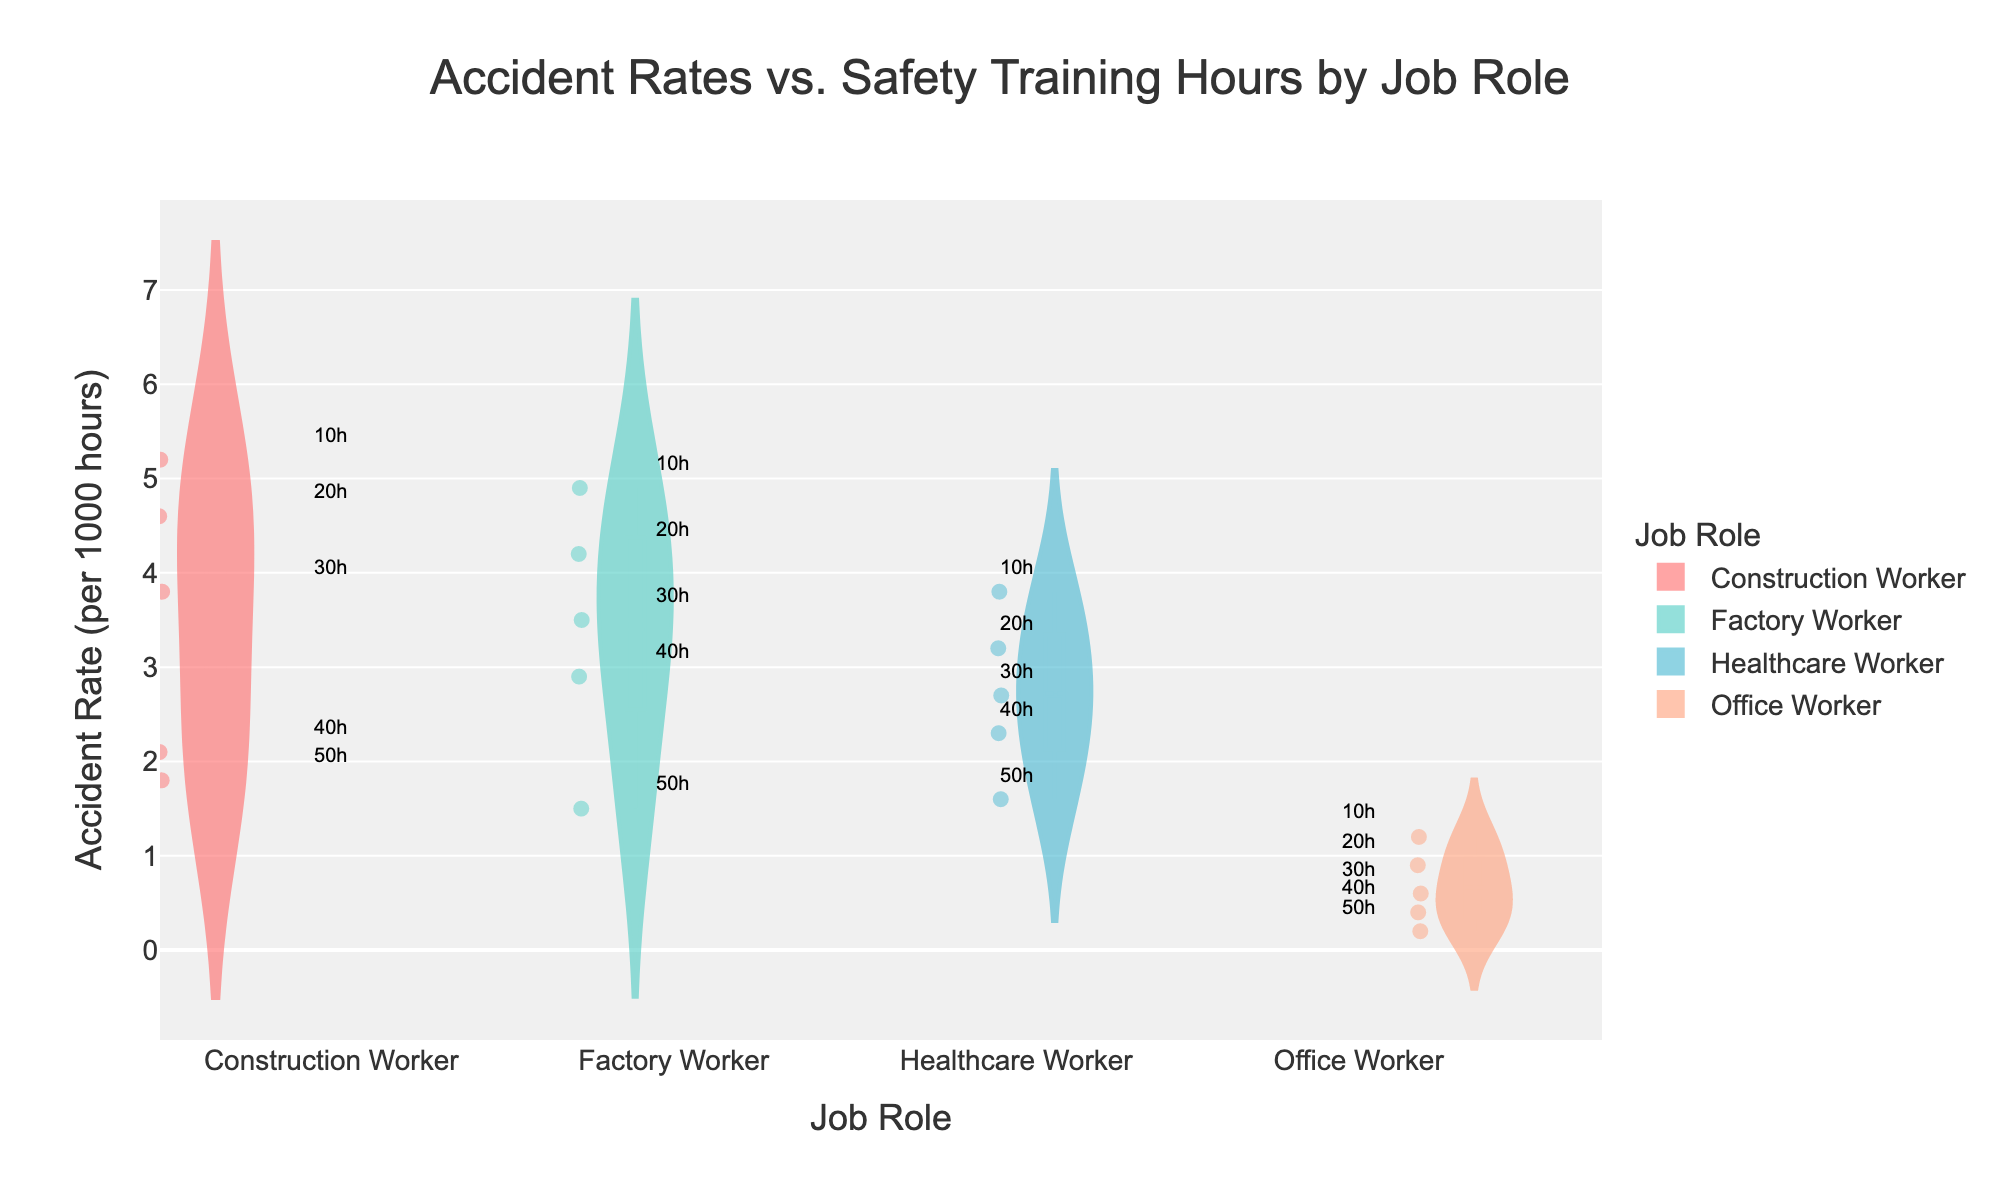What is the title of the figure? The title is displayed at the top center of the figure.
Answer: Accident Rates vs. Safety Training Hours by Job Role How many job roles are compared in the figure? The figure shows distinct violin plots for each job role, and there are four unique job roles.
Answer: Four Which job role has the highest accident rate for 10 hours of safety training? Look for the points marked with "10h" on each violin plot. The highest point for 10 hours of safety training is for Construction Workers.
Answer: Construction Worker Compare the accident rates for Factory Workers and Healthcare Workers at 50 hours of safety training. Which is lower? Locate the points marked "50h" within the Factory Worker and Healthcare Worker violin plots and compare their vertical positions. The Factory Worker has a lower accident rate compared to the Healthcare Worker at 50 hours.
Answer: Factory Worker What is the range of accident rates for Office Workers? Identify the lowest and highest accident rates for Office Workers by examining the spread of the points in the Office Worker violin plot. The range is from 0.2 to 1.2.
Answer: 0.2 to 1.2 Which job role shows the greatest decrease in accident rate from 10 to 50 hours of safety training? Calculate the difference in accident rate between 10 and 50 hours of safety training for each job role. The differences are: Construction Worker (5.2 - 1.8 = 3.4), Factory Worker (4.9 - 1.5 = 3.4), Healthcare Worker (3.8 - 1.6 = 2.2), Office Worker (1.2 - 0.2 = 1.0). Construction Worker and Factory Worker both show the greatest decrease of 3.4.
Answer: Construction Worker and Factory Worker What is the accident rate for Healthcare Workers at 40 hours of safety training? Look for the point labeled "40h" within the Healthcare Worker violin plot and its corresponding accident rate value.
Answer: 2.3 per 1000 hours Which job role has the narrowest spread of accident rates? Examine the width of each violin plot to see which has the smallest spread from minimum to maximum accident rates. The Office Worker plot has the narrowest spread.
Answer: Office Worker 